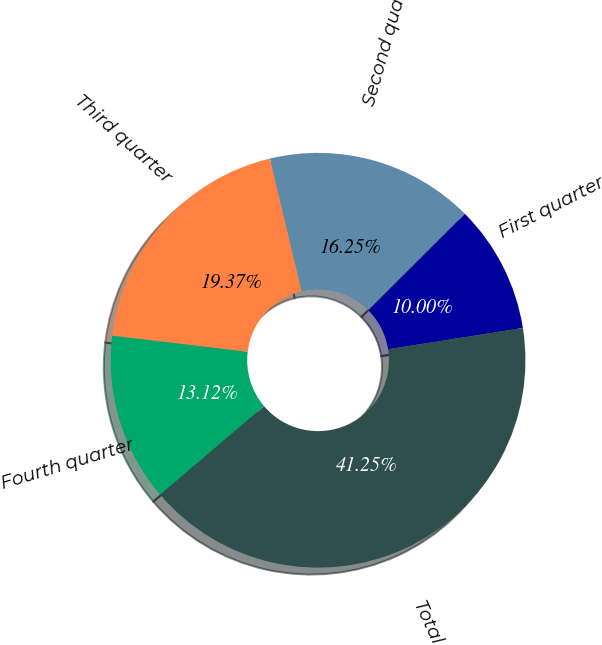Convert chart to OTSL. <chart><loc_0><loc_0><loc_500><loc_500><pie_chart><fcel>First quarter<fcel>Second quarter<fcel>Third quarter<fcel>Fourth quarter<fcel>Total<nl><fcel>10.0%<fcel>16.25%<fcel>19.37%<fcel>13.12%<fcel>41.25%<nl></chart> 